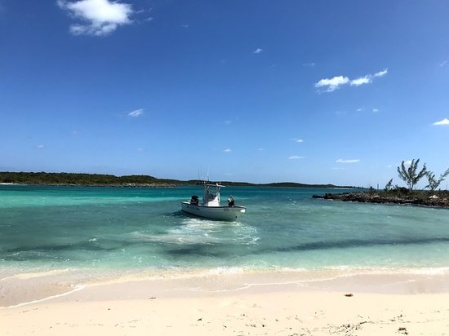If this scene were the opening of a film, how would the narrative unfold? The scene opens with a wide shot of the tranquil, turquoise ocean, capturing the small boat moving gently towards the right. As the camera zooms in, we see a protagonist aboard the boat, perhaps a young adventurer or a seasoned sailor, gazing thoughtfully at the horizon. The serene setting is juxtaposed with the character’s intense look, hinting at a deeper, hidden conflict or quest. The peaceful beach and lush island suggest a refuge, but the underlying tension forebodes an impending journey or challenge.

The narrative could unfold with the protagonist docking on the island, embarking on a search for something or someone lost. Flashbacks reveal glimpses of a heartfelt backstory, driving their current mission. As the film progresses, the idyllic setting contrasts with darker, more challenging undertakings, blending moments of serenity with high-stakes adventure and emotional depth. The pristine surroundings serve not just as a backdrop but as an integral part of the narrative, reflecting both the beauty and the peril of the hero's journey. What unexpected twist might we encounter in this story? As the protagonist explores the island, they stumble upon ancient, cryptic symbols etched into the rocks, leading them to realize that the island holds a secret far older and more powerful than they initially imagined. This revelation brings about a thrilling twist: the island once belonged to an ancient civilization, and its secrets have the potential to alter the course of human history. Perhaps, upon further investigation, the protagonist discovers that they are not alone; others have also come seeking the island's secrets—some with benevolent intentions and others with malicious ambitions. This discovery sets off a high-stakes race against time to uncover and protect the ancient legacy from falling into the wrong hands, leading to electrifying confrontations and alliances. 